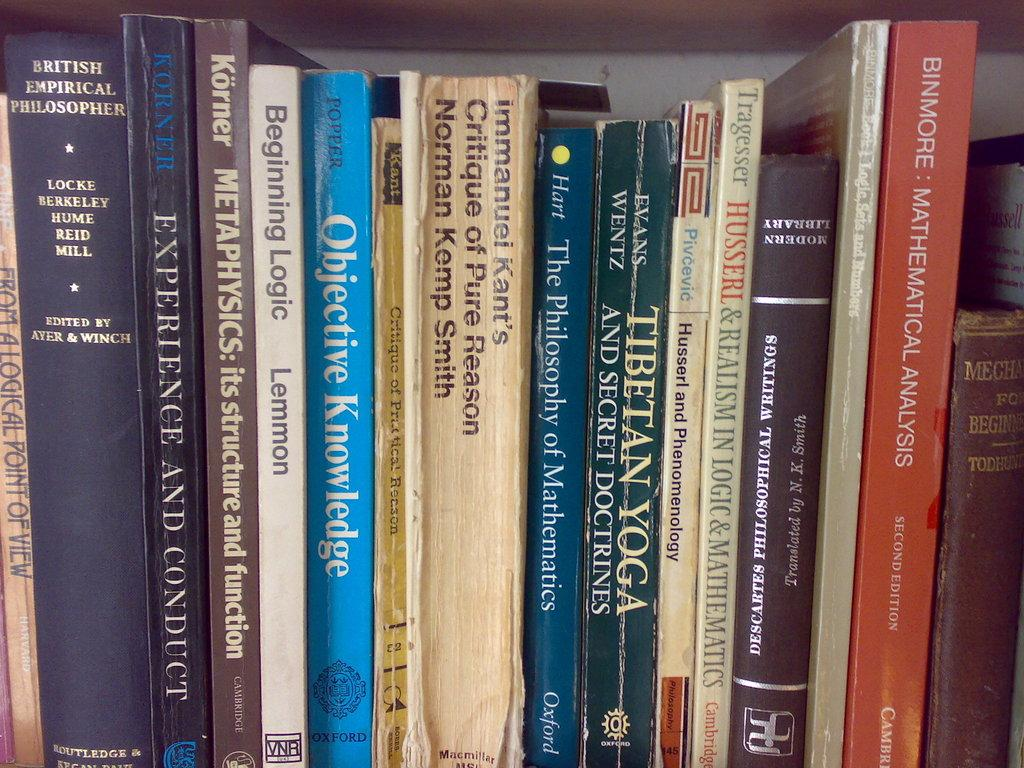<image>
Offer a succinct explanation of the picture presented. Various books on a shelf including the book "Tibetan Yoga and Secret Doctrines" 